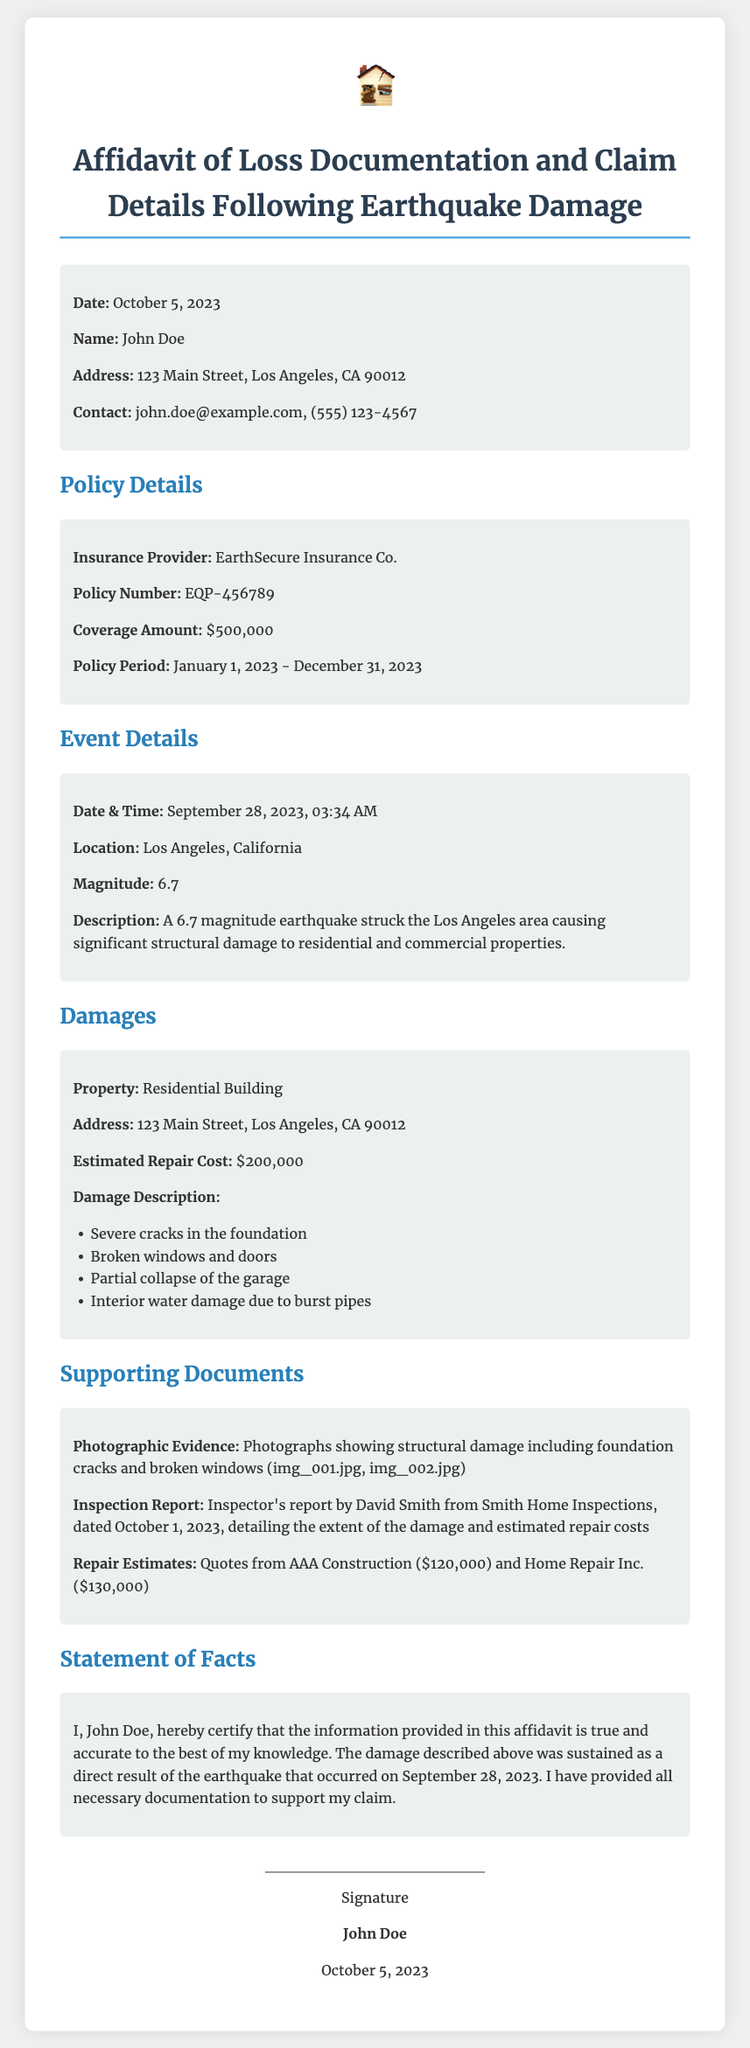What is the date of the affidavit? The date is specified in the document as October 5, 2023.
Answer: October 5, 2023 Who is the insured party? The insured party's name is mentioned at the beginning of the document as John Doe.
Answer: John Doe What is the policy number? The policy number is a specific detail provided under Policy Details, which is EQP-456789.
Answer: EQP-456789 What is the estimated repair cost? The estimated repair cost for the damages is provided in the Damages section as $200,000.
Answer: $200,000 What magnitude was the earthquake? The document states that the earthquake had a magnitude of 6.7.
Answer: 6.7 What supporting document is dated October 1, 2023? The document mentions an inspection report by David Smith from Smith Home Inspections dated October 1, 2023.
Answer: Inspection Report What is the address of the damaged property? The address of the property is listed in multiple sections as 123 Main Street, Los Angeles, CA 90012.
Answer: 123 Main Street, Los Angeles, CA 90012 What does the signer certify? The signer certifies that the information provided in the affidavit is true and accurate to the best of their knowledge.
Answer: True and accurate What insurance provider is mentioned? The insurance provider is clearly indicated in the document as EarthSecure Insurance Co.
Answer: EarthSecure Insurance Co 